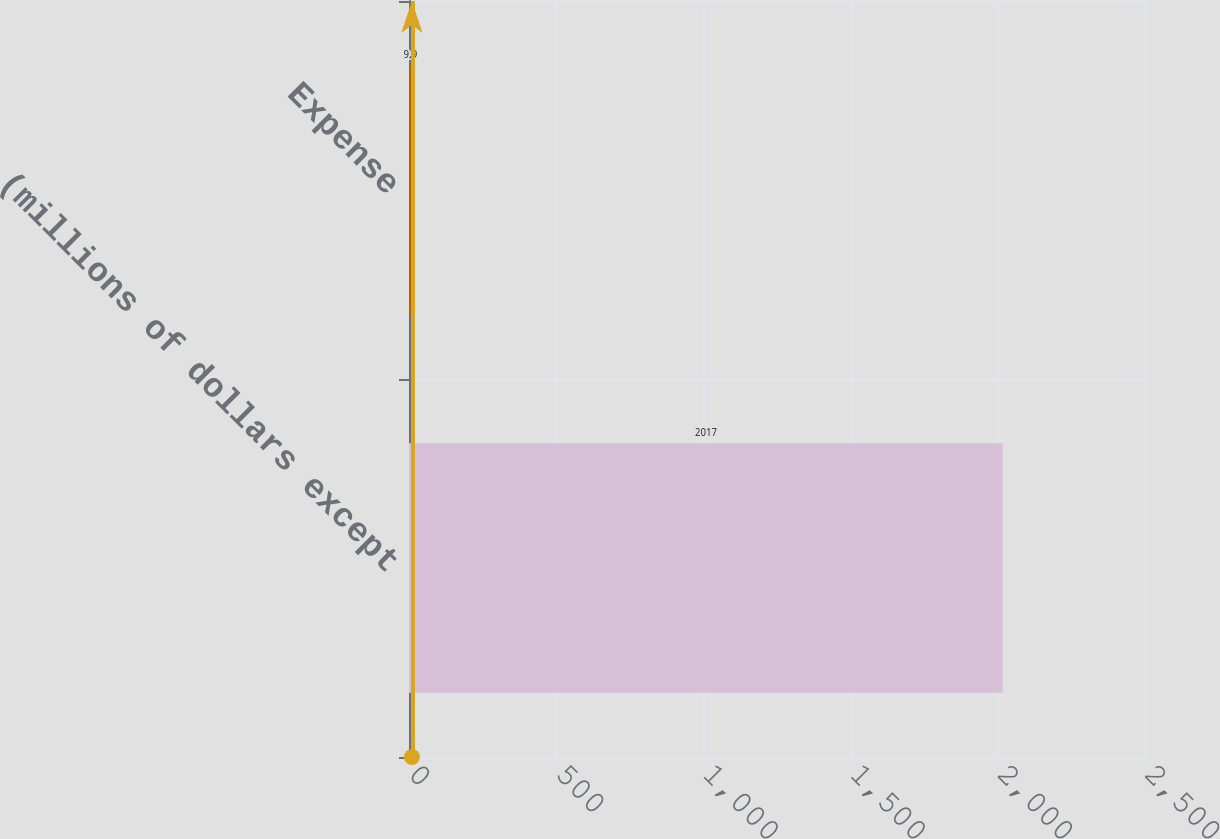Convert chart. <chart><loc_0><loc_0><loc_500><loc_500><bar_chart><fcel>(millions of dollars except<fcel>Expense<nl><fcel>2017<fcel>9.9<nl></chart> 